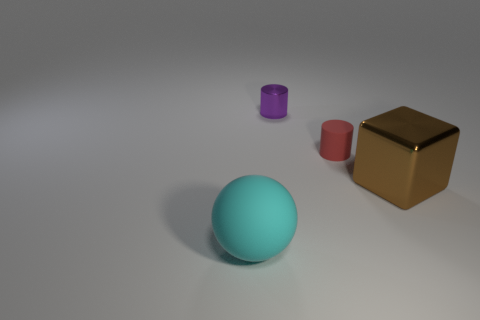Are there more small things that are left of the big block than large objects left of the matte cylinder?
Make the answer very short. Yes. What size is the red thing that is made of the same material as the large cyan object?
Offer a terse response. Small. There is a big thing right of the large cyan thing; what number of rubber things are behind it?
Your response must be concise. 1. Are there any small red matte objects of the same shape as the tiny purple object?
Make the answer very short. Yes. What is the color of the large object that is behind the matte object on the left side of the small purple thing?
Keep it short and to the point. Brown. Is the number of blocks greater than the number of gray cylinders?
Your answer should be very brief. Yes. What number of other things have the same size as the red matte object?
Give a very brief answer. 1. Are the big ball and the large object that is to the right of the cyan ball made of the same material?
Provide a short and direct response. No. Is the number of big cyan balls less than the number of yellow matte cylinders?
Give a very brief answer. No. Is there anything else that is the same color as the tiny metallic thing?
Your response must be concise. No. 